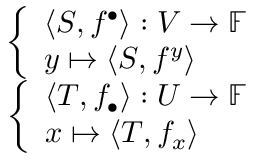<formula> <loc_0><loc_0><loc_500><loc_500>\begin{array} { r } { { \left \{ \begin{array} { l l } { \langle S , f ^ { \bullet } \rangle \colon V \to \mathbb { F } } \\ { y \mapsto \langle S , f ^ { y } \rangle } \end{array} } } \\ { { \left \{ \begin{array} { l l } { \langle T , f _ { \bullet } \rangle \colon U \to \mathbb { F } } \\ { x \mapsto \langle T , f _ { x } \rangle } \end{array} } } \end{array}</formula> 